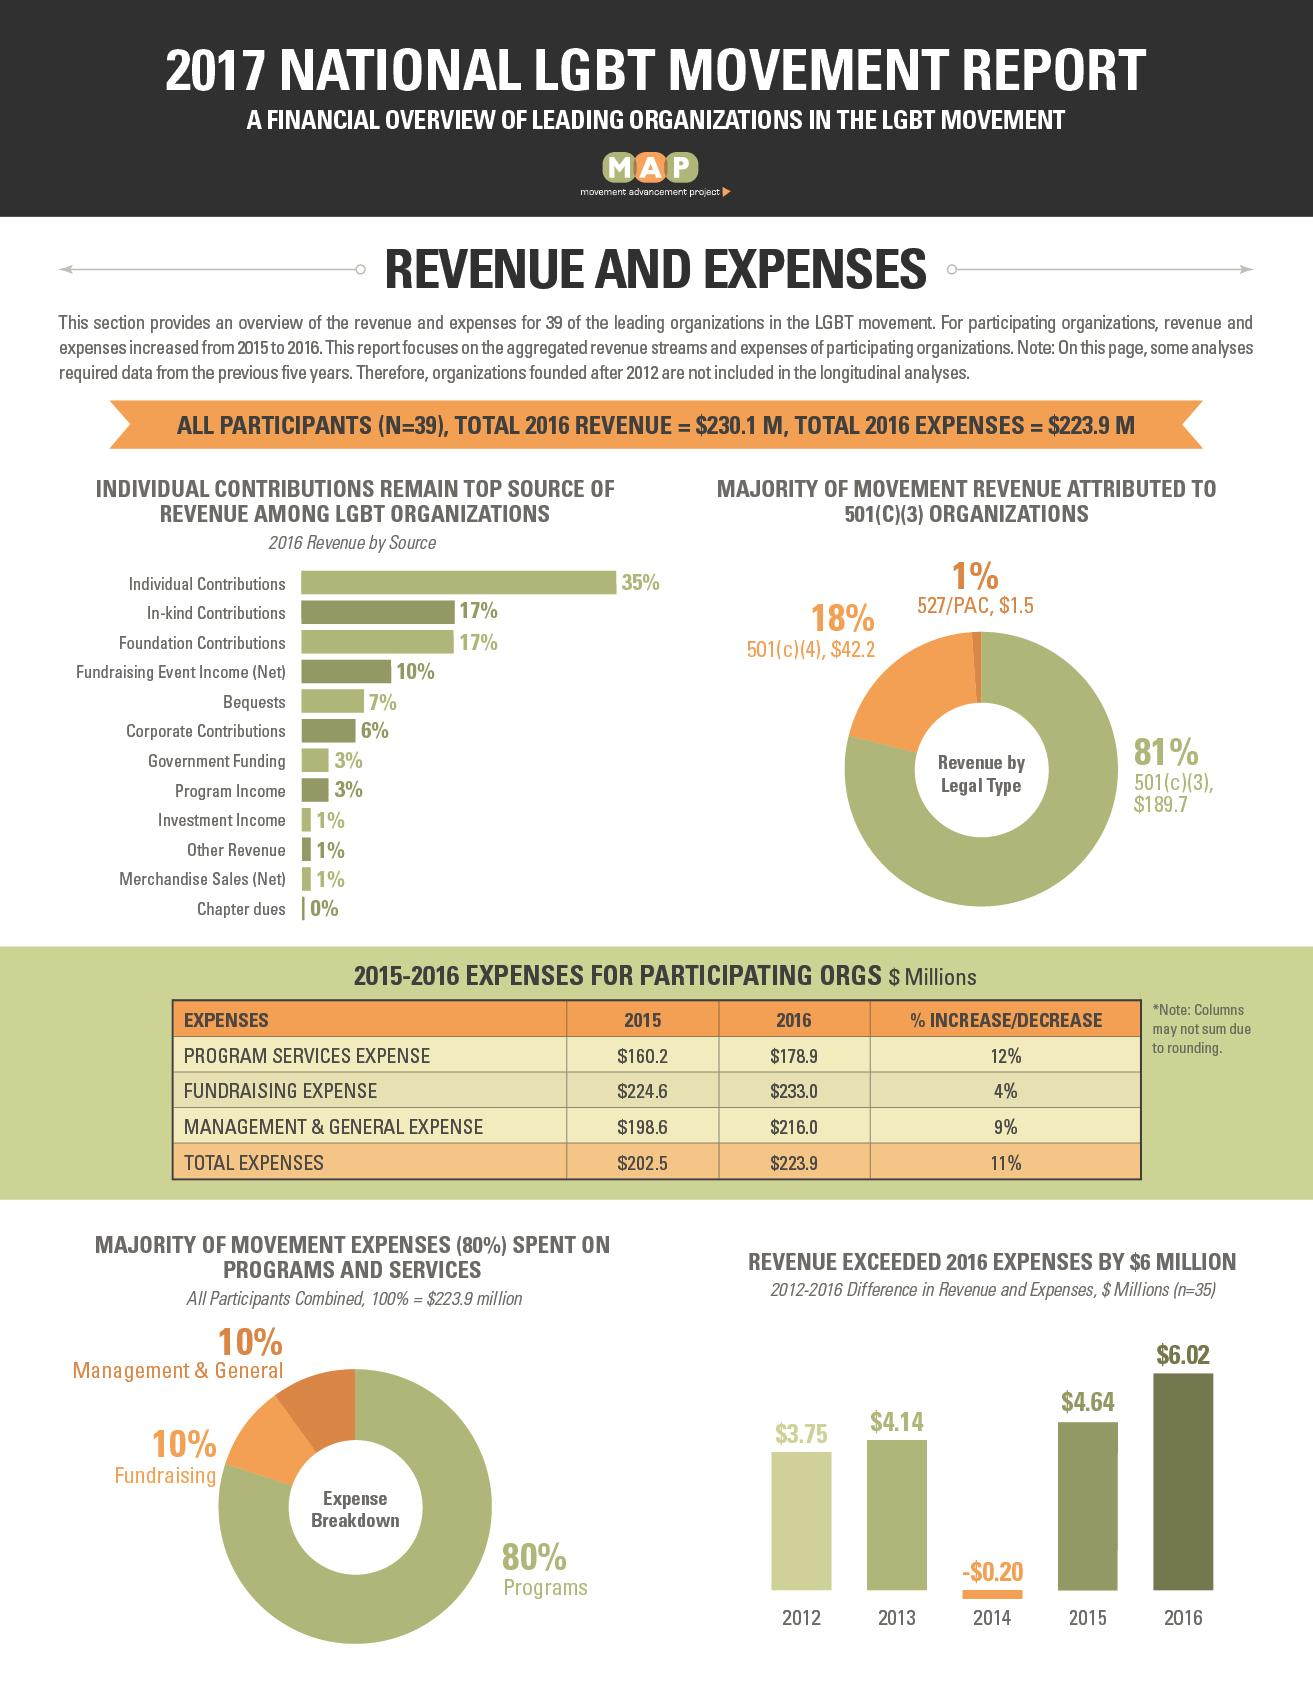Outline some significant characteristics in this image. In total, individual contributions and bequests accounted for 42% of the museum's annual revenue. Taken together, programs and fundraising account for approximately 90% of total revenue. The color that represents the programs is grey. There are a total of 5 years in the bar graph. The combined revenue from chapter dues and other sources is 1%. 